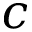Convert formula to latex. <formula><loc_0><loc_0><loc_500><loc_500>c</formula> 